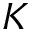<formula> <loc_0><loc_0><loc_500><loc_500>K</formula> 